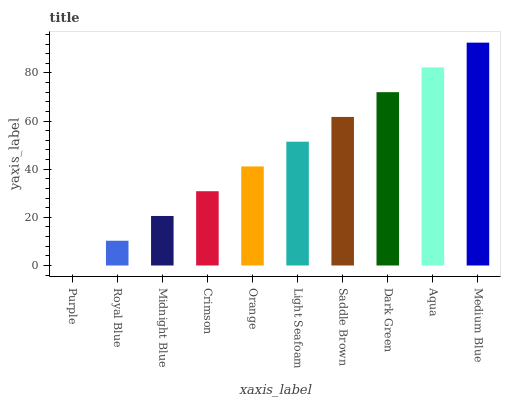Is Purple the minimum?
Answer yes or no. Yes. Is Medium Blue the maximum?
Answer yes or no. Yes. Is Royal Blue the minimum?
Answer yes or no. No. Is Royal Blue the maximum?
Answer yes or no. No. Is Royal Blue greater than Purple?
Answer yes or no. Yes. Is Purple less than Royal Blue?
Answer yes or no. Yes. Is Purple greater than Royal Blue?
Answer yes or no. No. Is Royal Blue less than Purple?
Answer yes or no. No. Is Light Seafoam the high median?
Answer yes or no. Yes. Is Orange the low median?
Answer yes or no. Yes. Is Medium Blue the high median?
Answer yes or no. No. Is Medium Blue the low median?
Answer yes or no. No. 